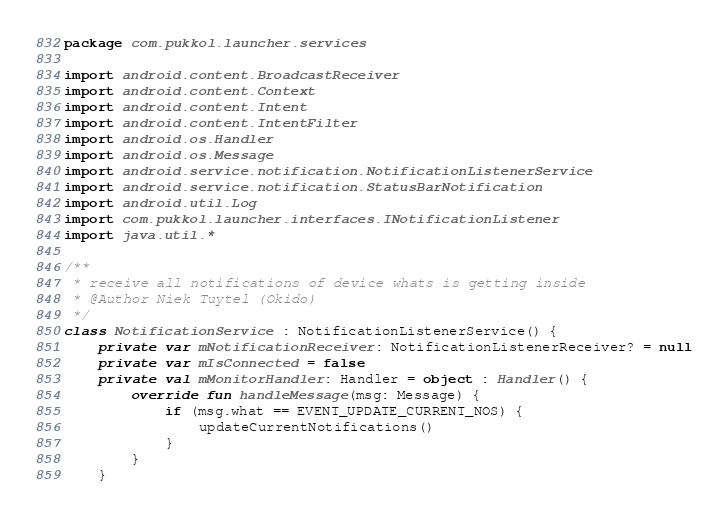Convert code to text. <code><loc_0><loc_0><loc_500><loc_500><_Kotlin_>package com.pukkol.launcher.services

import android.content.BroadcastReceiver
import android.content.Context
import android.content.Intent
import android.content.IntentFilter
import android.os.Handler
import android.os.Message
import android.service.notification.NotificationListenerService
import android.service.notification.StatusBarNotification
import android.util.Log
import com.pukkol.launcher.interfaces.INotificationListener
import java.util.*

/**
 * receive all notifications of device whats is getting inside
 * @Author Niek Tuytel (Okido)
 */
class NotificationService : NotificationListenerService() {
    private var mNotificationReceiver: NotificationListenerReceiver? = null
    private var mIsConnected = false
    private val mMonitorHandler: Handler = object : Handler() {
        override fun handleMessage(msg: Message) {
            if (msg.what == EVENT_UPDATE_CURRENT_NOS) {
                updateCurrentNotifications()
            }
        }
    }
</code> 